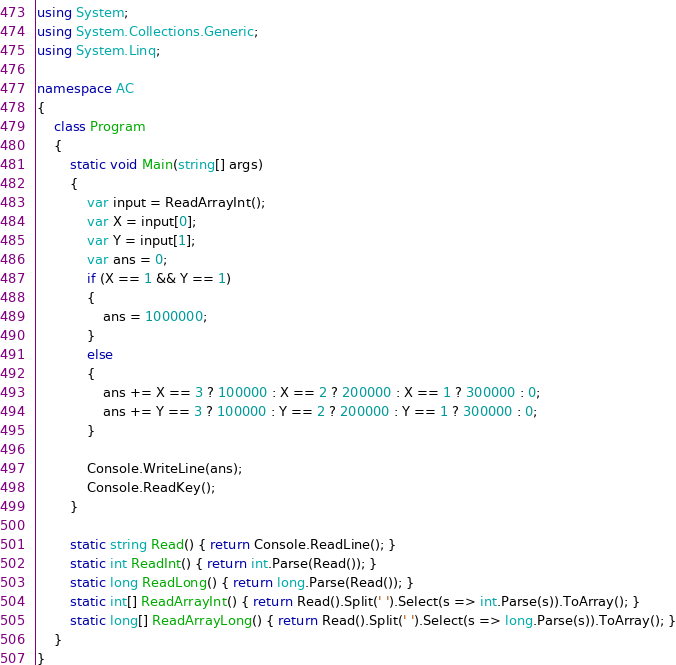<code> <loc_0><loc_0><loc_500><loc_500><_C#_>using System;
using System.Collections.Generic;
using System.Linq;

namespace AC
{
    class Program
    {
        static void Main(string[] args)
        {
            var input = ReadArrayInt();
            var X = input[0];
            var Y = input[1];
            var ans = 0;
            if (X == 1 && Y == 1)
            {
                ans = 1000000;
            }
            else
            {
                ans += X == 3 ? 100000 : X == 2 ? 200000 : X == 1 ? 300000 : 0;
                ans += Y == 3 ? 100000 : Y == 2 ? 200000 : Y == 1 ? 300000 : 0;
            }

            Console.WriteLine(ans);
            Console.ReadKey();
        }

        static string Read() { return Console.ReadLine(); }
        static int ReadInt() { return int.Parse(Read()); }
        static long ReadLong() { return long.Parse(Read()); }
        static int[] ReadArrayInt() { return Read().Split(' ').Select(s => int.Parse(s)).ToArray(); }
        static long[] ReadArrayLong() { return Read().Split(' ').Select(s => long.Parse(s)).ToArray(); }
    }
}</code> 